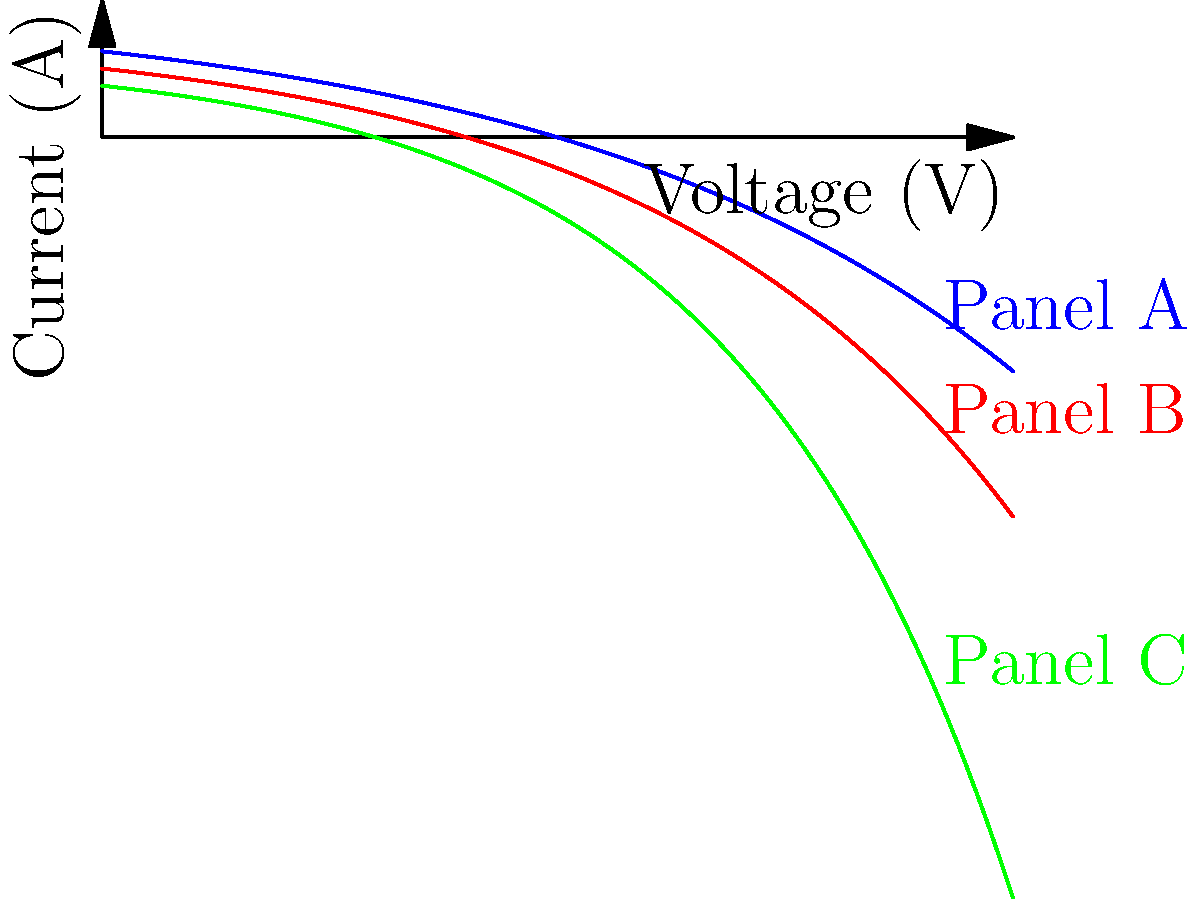Based on the I-V curves shown for three different solar panel types (A, B, and C), which panel would require the inverter to operate at the highest voltage to achieve its maximum power point? To determine which panel requires the highest voltage for its maximum power point, we need to analyze the I-V curves:

1. The maximum power point (MPP) for each panel occurs at the "knee" of its I-V curve, where the product of current and voltage is highest.

2. Panel A (blue curve):
   - Has the highest current output
   - The knee of the curve occurs at a relatively high voltage

3. Panel B (red curve):
   - Has a moderate current output
   - The knee of the curve occurs at a slightly lower voltage than Panel A

4. Panel C (green curve):
   - Has the lowest current output
   - The knee of the curve occurs at the lowest voltage among the three panels

5. Comparing the curves, we can see that Panel A's knee point is at the highest voltage, followed by Panel B, and then Panel C.

6. The inverter would need to operate at the highest voltage to achieve the maximum power point for Panel A.

Therefore, Panel A requires the inverter to operate at the highest voltage to achieve its maximum power point.
Answer: Panel A 